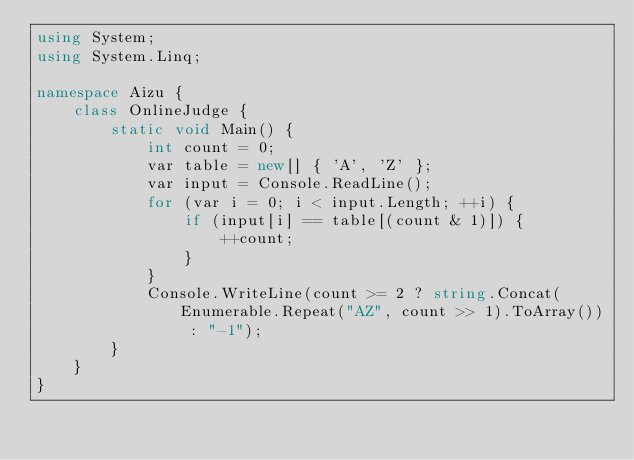<code> <loc_0><loc_0><loc_500><loc_500><_C#_>using System;
using System.Linq;

namespace Aizu {
    class OnlineJudge {
        static void Main() {
            int count = 0;
            var table = new[] { 'A', 'Z' };
            var input = Console.ReadLine();
            for (var i = 0; i < input.Length; ++i) {
                if (input[i] == table[(count & 1)]) {
                    ++count;
                }
            }
            Console.WriteLine(count >= 2 ? string.Concat(Enumerable.Repeat("AZ", count >> 1).ToArray()) : "-1");
        }
    }
}</code> 